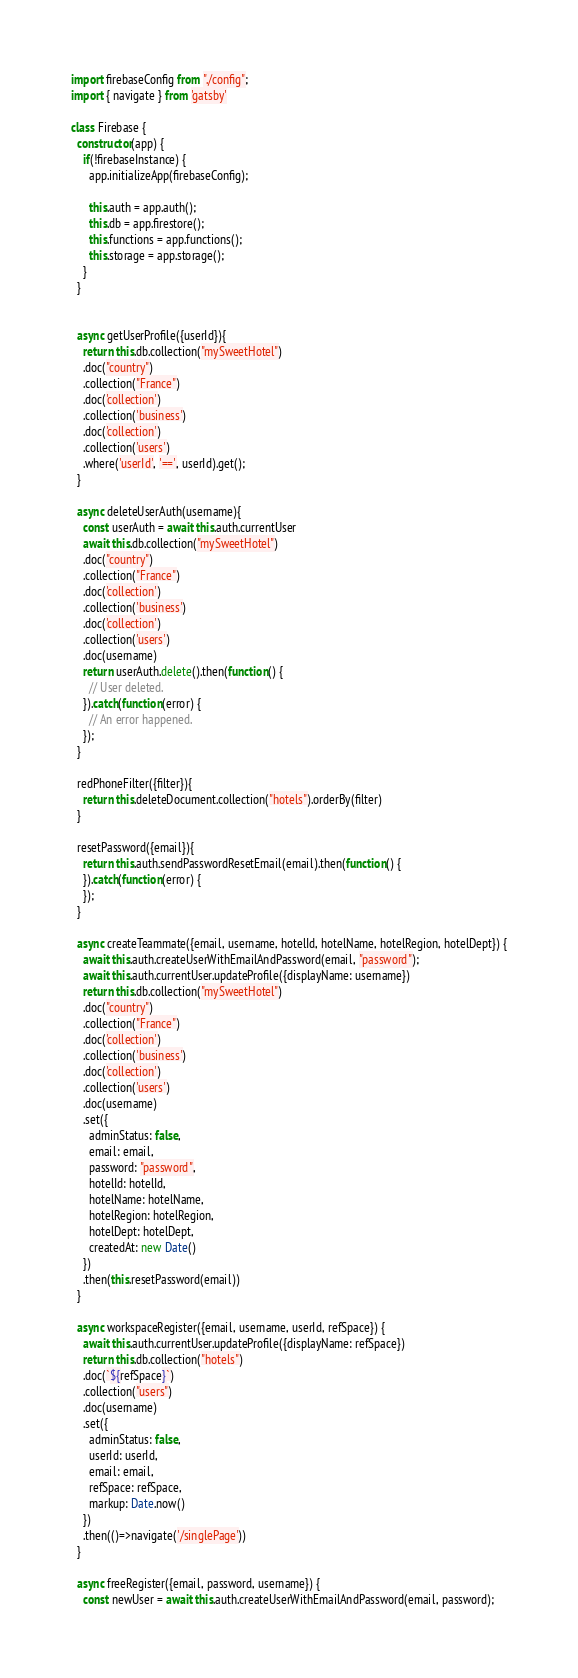<code> <loc_0><loc_0><loc_500><loc_500><_JavaScript_>import firebaseConfig from "./config";
import { navigate } from 'gatsby'

class Firebase {
  constructor(app) {
    if(!firebaseInstance) {
      app.initializeApp(firebaseConfig);

      this.auth = app.auth();
      this.db = app.firestore();
      this.functions = app.functions();
      this.storage = app.storage();
    }
  }


  async getUserProfile({userId}){
    return this.db.collection("mySweetHotel")
    .doc("country")
    .collection("France")
    .doc('collection')
    .collection('business')
    .doc('collection')
    .collection('users')
    .where('userId', '==', userId).get();
  }

  async deleteUserAuth(username){
    const userAuth = await this.auth.currentUser
    await this.db.collection("mySweetHotel")
    .doc("country")
    .collection("France")
    .doc('collection')
    .collection('business')
    .doc('collection')
    .collection('users')
    .doc(username)
    return userAuth.delete().then(function() {
      // User deleted.
    }).catch(function(error) {
      // An error happened.
    });
  }
  
  redPhoneFilter({filter}){
    return this.deleteDocument.collection("hotels").orderBy(filter)
  }

  resetPassword({email}){
    return this.auth.sendPasswordResetEmail(email).then(function() {
    }).catch(function(error) {
    });
  }

  async createTeammate({email, username, hotelId, hotelName, hotelRegion, hotelDept}) {
    await this.auth.createUserWithEmailAndPassword(email, "password");
    await this.auth.currentUser.updateProfile({displayName: username})
    return this.db.collection("mySweetHotel")
    .doc("country")
    .collection("France")
    .doc('collection')
    .collection('business')
    .doc('collection')
    .collection('users')
    .doc(username)
    .set({   
      adminStatus: false, 
      email: email,
      password: "password",
      hotelId: hotelId,
      hotelName: hotelName,
      hotelRegion: hotelRegion,
      hotelDept: hotelDept,
      createdAt: new Date()
    }) 
    .then(this.resetPassword(email))   
  }

  async workspaceRegister({email, username, userId, refSpace}) {
    await this.auth.currentUser.updateProfile({displayName: refSpace})
    return this.db.collection("hotels")
    .doc(`${refSpace}`)
    .collection("users")
    .doc(username)
    .set({    
      adminStatus: false, 
      userId: userId,
      email: email,
      refSpace: refSpace,
      markup: Date.now()
    }) 
    .then(()=>navigate('/singlePage'))   
  }

  async freeRegister({email, password, username}) {
    const newUser = await this.auth.createUserWithEmailAndPassword(email, password);</code> 